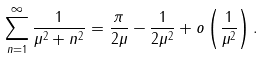Convert formula to latex. <formula><loc_0><loc_0><loc_500><loc_500>\sum _ { n = 1 } ^ { \infty } \frac { 1 } { \mu ^ { 2 } + n ^ { 2 } } = \frac { \pi } { 2 \mu } - \frac { 1 } { 2 \mu ^ { 2 } } + o \left ( \frac { 1 } { \mu ^ { 2 } } \right ) .</formula> 